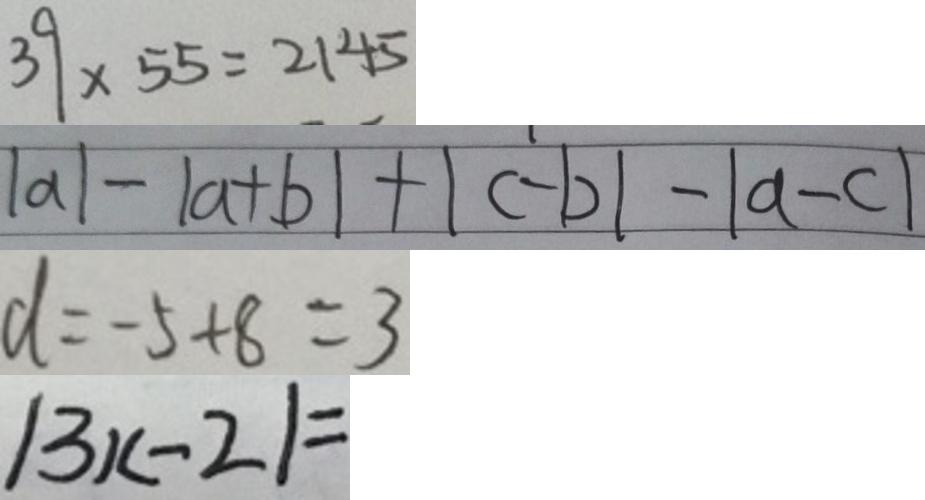Convert formula to latex. <formula><loc_0><loc_0><loc_500><loc_500>3 9 \times 5 5 = 2 1 4 5 
 \vert a \vert - \vert a + b \vert + \vert c - b \vert - \vert a - c \vert 
 d = - 5 + 8 = 3 
 \vert 3 x - 2 \vert =</formula> 